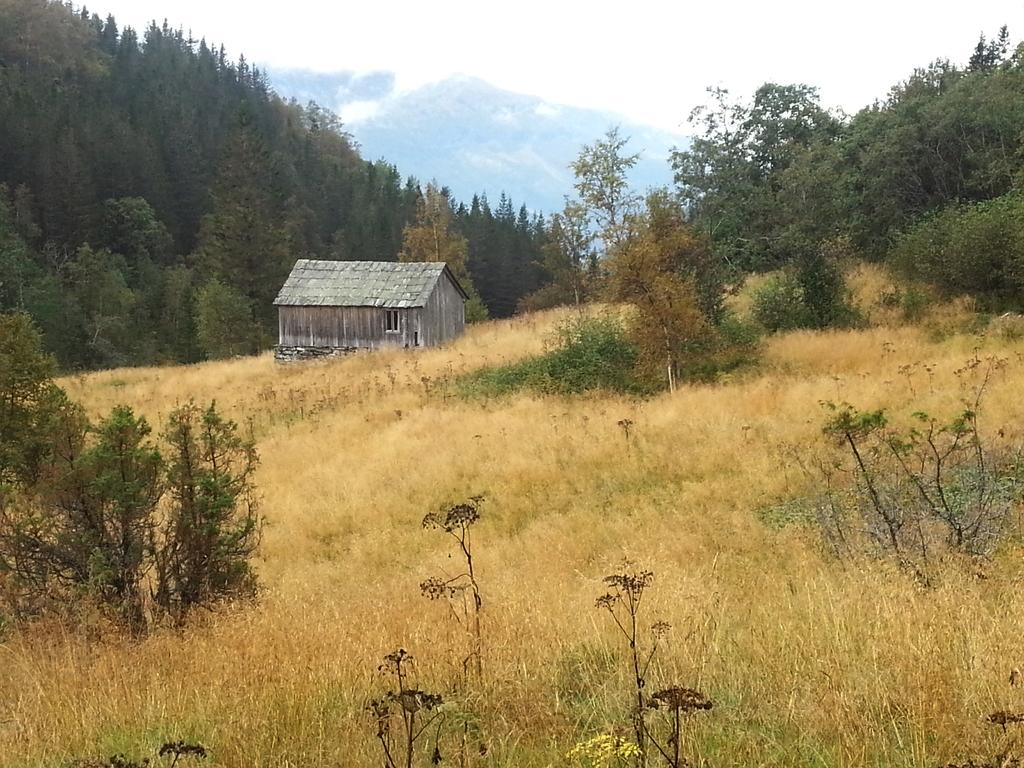What is the overall color tone of the image? The image has an ash color shade. What type of structure can be seen in the image? There is a shed in the image. What type of vegetation is present near the shed? Grass and plants are visible near the shed. What can be seen in the background of the image? There are many trees, mountains, and the sky visible in the background of the image. Which actor is performing in the image? There are no actors or performances present in the image; it features a shed, vegetation, and a background with trees, mountains, and the sky. How does the wind affect the plants in the image? There is no indication of wind in the image, so its effect on the plants cannot be determined. 